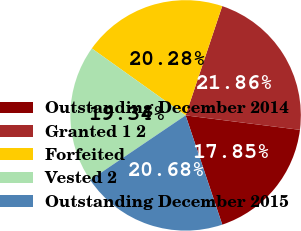Convert chart to OTSL. <chart><loc_0><loc_0><loc_500><loc_500><pie_chart><fcel>Outstanding December 2014<fcel>Granted 1 2<fcel>Forfeited<fcel>Vested 2<fcel>Outstanding December 2015<nl><fcel>17.85%<fcel>21.86%<fcel>20.28%<fcel>19.34%<fcel>20.68%<nl></chart> 